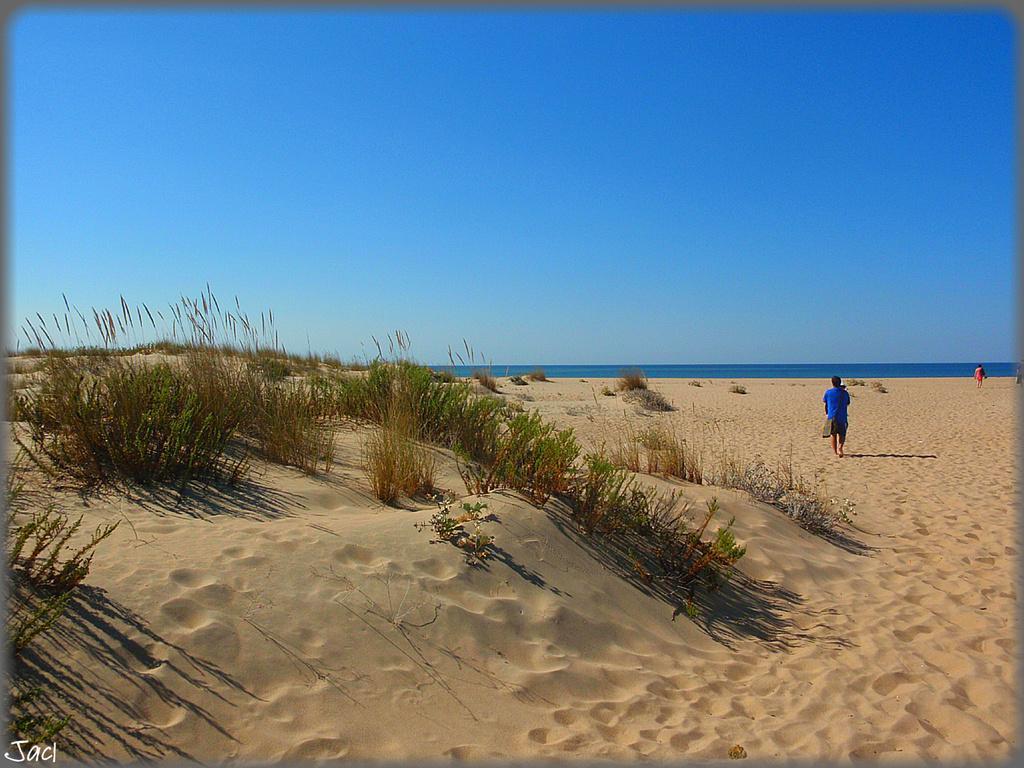Could you give a brief overview of what you see in this image? Here we can see grass on the sand and on the right there are two persons walking on the sand. In the background we can see water and sky. 